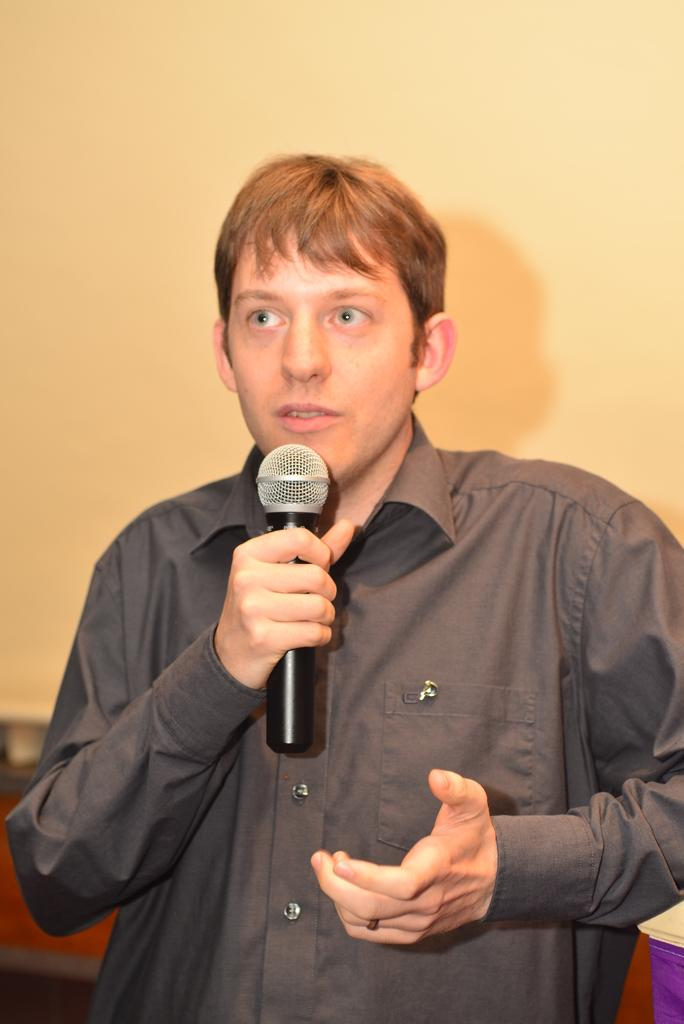Who is present in the image? There is a man in the image. What is the man holding in his hand? The man is holding a mic in his hand. What type of key is the man using to unlock the plot in the image? There is no key or plot present in the image; it features a man holding a mic. What type of whip is the man using to control the audience in the image? There is no whip present in the image; it features a man holding a mic. 